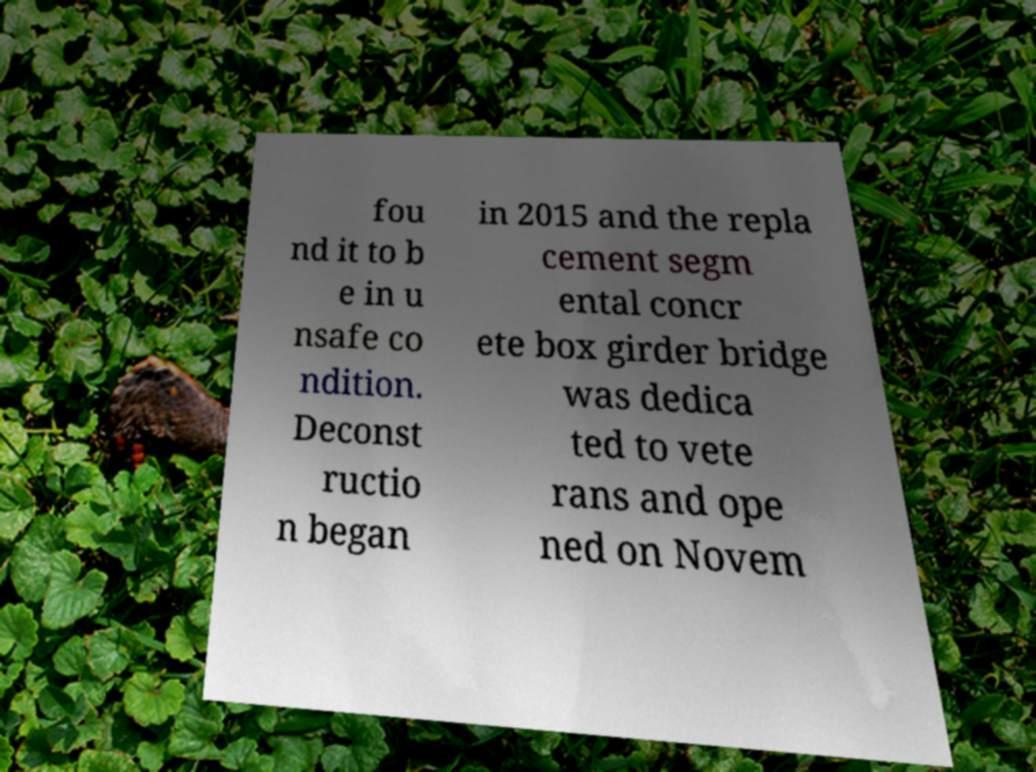I need the written content from this picture converted into text. Can you do that? fou nd it to b e in u nsafe co ndition. Deconst ructio n began in 2015 and the repla cement segm ental concr ete box girder bridge was dedica ted to vete rans and ope ned on Novem 